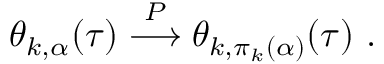<formula> <loc_0><loc_0><loc_500><loc_500>\theta _ { k , \alpha } ( \tau ) \stackrel { P } { \longrightarrow } \theta _ { k , \pi _ { k } ( \alpha ) } ( \tau ) .</formula> 